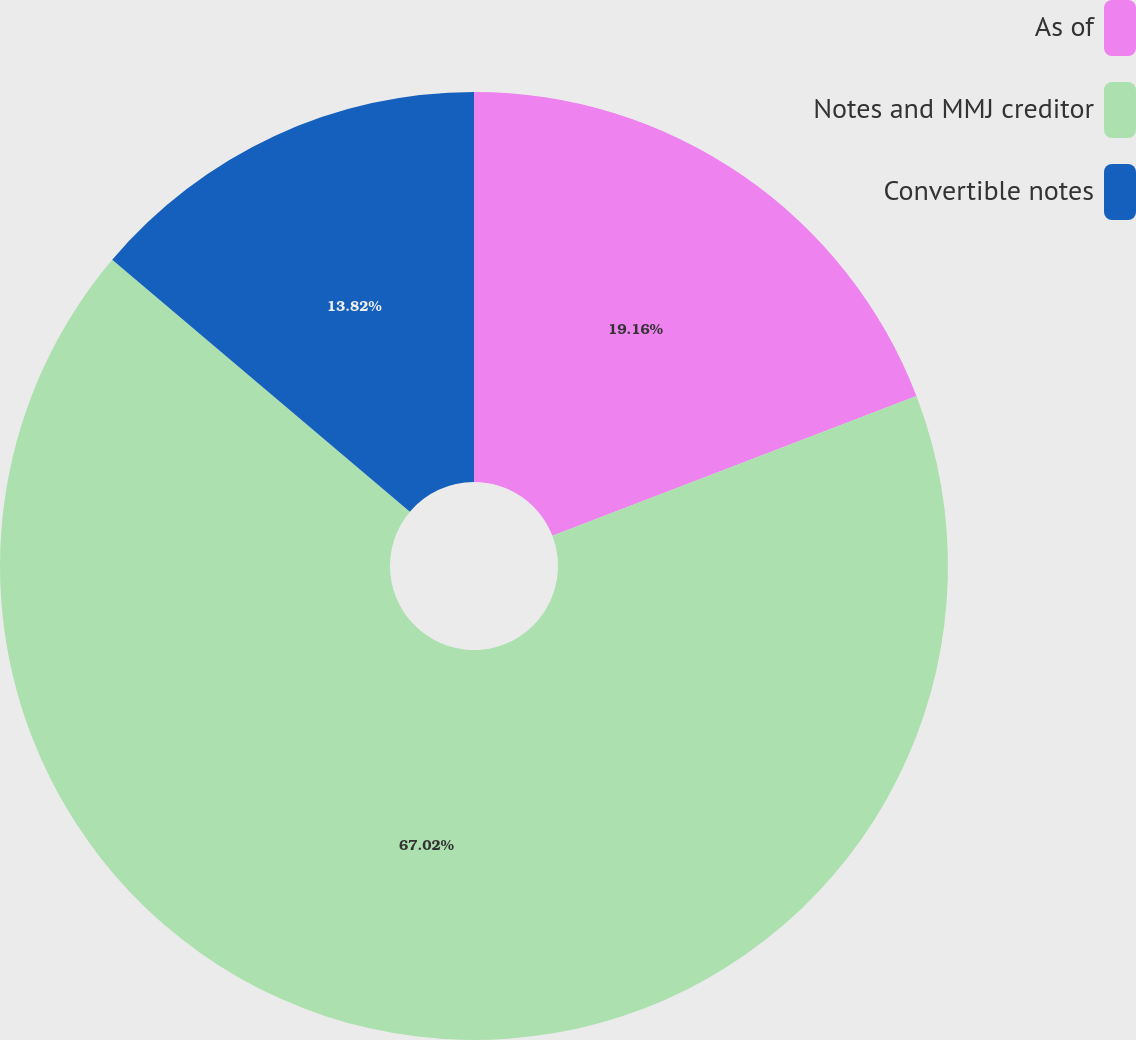Convert chart. <chart><loc_0><loc_0><loc_500><loc_500><pie_chart><fcel>As of<fcel>Notes and MMJ creditor<fcel>Convertible notes<nl><fcel>19.16%<fcel>67.02%<fcel>13.82%<nl></chart> 